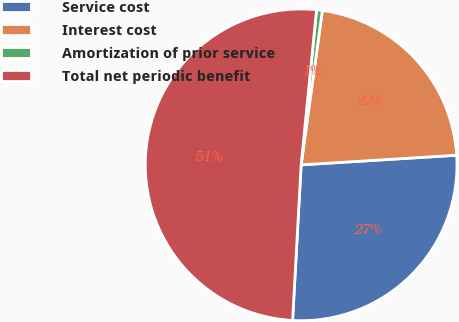<chart> <loc_0><loc_0><loc_500><loc_500><pie_chart><fcel>Service cost<fcel>Interest cost<fcel>Amortization of prior service<fcel>Total net periodic benefit<nl><fcel>26.85%<fcel>21.84%<fcel>0.6%<fcel>50.7%<nl></chart> 